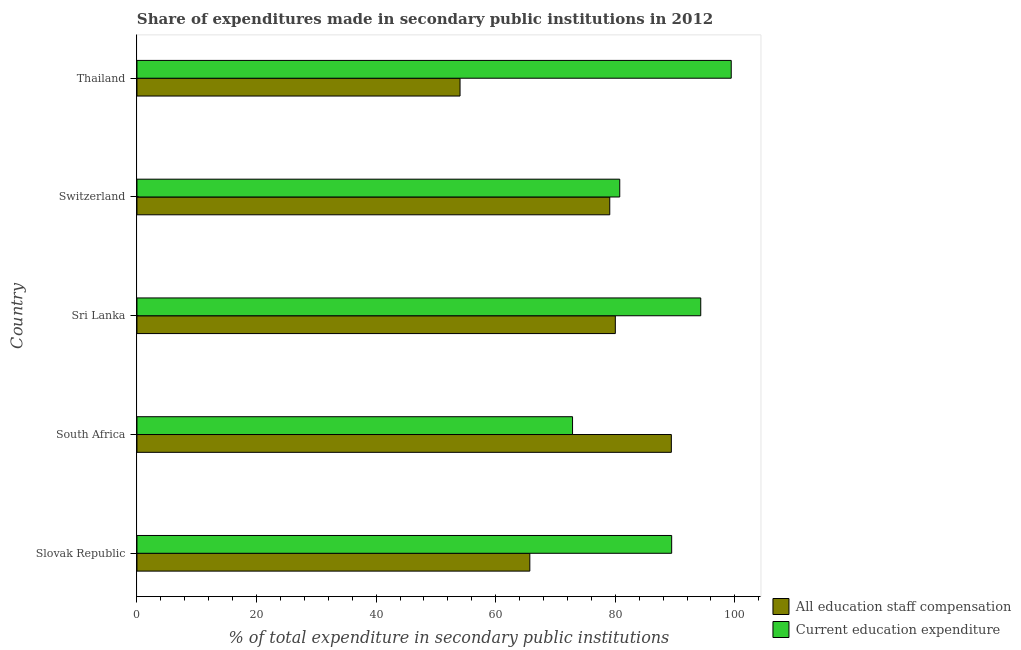Are the number of bars per tick equal to the number of legend labels?
Your response must be concise. Yes. What is the label of the 4th group of bars from the top?
Provide a succinct answer. South Africa. In how many cases, is the number of bars for a given country not equal to the number of legend labels?
Offer a very short reply. 0. What is the expenditure in education in Thailand?
Your answer should be compact. 99.39. Across all countries, what is the maximum expenditure in education?
Your response must be concise. 99.39. Across all countries, what is the minimum expenditure in staff compensation?
Offer a terse response. 54.03. In which country was the expenditure in staff compensation maximum?
Keep it short and to the point. South Africa. In which country was the expenditure in education minimum?
Provide a short and direct response. South Africa. What is the total expenditure in staff compensation in the graph?
Provide a short and direct response. 368.19. What is the difference between the expenditure in education in Sri Lanka and that in Thailand?
Ensure brevity in your answer.  -5.1. What is the difference between the expenditure in education in Sri Lanka and the expenditure in staff compensation in Thailand?
Provide a succinct answer. 40.26. What is the average expenditure in education per country?
Keep it short and to the point. 87.34. What is the difference between the expenditure in staff compensation and expenditure in education in South Africa?
Provide a succinct answer. 16.52. In how many countries, is the expenditure in staff compensation greater than 68 %?
Ensure brevity in your answer.  3. What is the ratio of the expenditure in staff compensation in Slovak Republic to that in Sri Lanka?
Your response must be concise. 0.82. Is the expenditure in staff compensation in Slovak Republic less than that in South Africa?
Ensure brevity in your answer.  Yes. What is the difference between the highest and the second highest expenditure in education?
Keep it short and to the point. 5.1. What is the difference between the highest and the lowest expenditure in staff compensation?
Ensure brevity in your answer.  35.34. In how many countries, is the expenditure in staff compensation greater than the average expenditure in staff compensation taken over all countries?
Ensure brevity in your answer.  3. Is the sum of the expenditure in staff compensation in South Africa and Thailand greater than the maximum expenditure in education across all countries?
Offer a very short reply. Yes. What does the 2nd bar from the top in Sri Lanka represents?
Give a very brief answer. All education staff compensation. What does the 2nd bar from the bottom in Thailand represents?
Offer a terse response. Current education expenditure. Are all the bars in the graph horizontal?
Your response must be concise. Yes. How many countries are there in the graph?
Your answer should be compact. 5. What is the difference between two consecutive major ticks on the X-axis?
Your answer should be compact. 20. Are the values on the major ticks of X-axis written in scientific E-notation?
Make the answer very short. No. Does the graph contain any zero values?
Offer a terse response. No. Where does the legend appear in the graph?
Offer a very short reply. Bottom right. What is the title of the graph?
Offer a very short reply. Share of expenditures made in secondary public institutions in 2012. Does "Domestic liabilities" appear as one of the legend labels in the graph?
Provide a succinct answer. No. What is the label or title of the X-axis?
Provide a succinct answer. % of total expenditure in secondary public institutions. What is the label or title of the Y-axis?
Make the answer very short. Country. What is the % of total expenditure in secondary public institutions in All education staff compensation in Slovak Republic?
Your answer should be very brief. 65.7. What is the % of total expenditure in secondary public institutions in Current education expenditure in Slovak Republic?
Offer a terse response. 89.43. What is the % of total expenditure in secondary public institutions in All education staff compensation in South Africa?
Ensure brevity in your answer.  89.37. What is the % of total expenditure in secondary public institutions of Current education expenditure in South Africa?
Your answer should be very brief. 72.85. What is the % of total expenditure in secondary public institutions in All education staff compensation in Sri Lanka?
Offer a terse response. 80. What is the % of total expenditure in secondary public institutions of Current education expenditure in Sri Lanka?
Ensure brevity in your answer.  94.29. What is the % of total expenditure in secondary public institutions in All education staff compensation in Switzerland?
Offer a very short reply. 79.07. What is the % of total expenditure in secondary public institutions in Current education expenditure in Switzerland?
Your response must be concise. 80.74. What is the % of total expenditure in secondary public institutions of All education staff compensation in Thailand?
Make the answer very short. 54.03. What is the % of total expenditure in secondary public institutions in Current education expenditure in Thailand?
Offer a very short reply. 99.39. Across all countries, what is the maximum % of total expenditure in secondary public institutions in All education staff compensation?
Your response must be concise. 89.37. Across all countries, what is the maximum % of total expenditure in secondary public institutions of Current education expenditure?
Provide a short and direct response. 99.39. Across all countries, what is the minimum % of total expenditure in secondary public institutions in All education staff compensation?
Make the answer very short. 54.03. Across all countries, what is the minimum % of total expenditure in secondary public institutions of Current education expenditure?
Your answer should be compact. 72.85. What is the total % of total expenditure in secondary public institutions in All education staff compensation in the graph?
Ensure brevity in your answer.  368.19. What is the total % of total expenditure in secondary public institutions in Current education expenditure in the graph?
Your response must be concise. 436.7. What is the difference between the % of total expenditure in secondary public institutions of All education staff compensation in Slovak Republic and that in South Africa?
Offer a terse response. -23.67. What is the difference between the % of total expenditure in secondary public institutions of Current education expenditure in Slovak Republic and that in South Africa?
Keep it short and to the point. 16.58. What is the difference between the % of total expenditure in secondary public institutions in All education staff compensation in Slovak Republic and that in Sri Lanka?
Offer a very short reply. -14.3. What is the difference between the % of total expenditure in secondary public institutions of Current education expenditure in Slovak Republic and that in Sri Lanka?
Ensure brevity in your answer.  -4.86. What is the difference between the % of total expenditure in secondary public institutions in All education staff compensation in Slovak Republic and that in Switzerland?
Your answer should be compact. -13.37. What is the difference between the % of total expenditure in secondary public institutions in Current education expenditure in Slovak Republic and that in Switzerland?
Your answer should be very brief. 8.68. What is the difference between the % of total expenditure in secondary public institutions in All education staff compensation in Slovak Republic and that in Thailand?
Give a very brief answer. 11.67. What is the difference between the % of total expenditure in secondary public institutions of Current education expenditure in Slovak Republic and that in Thailand?
Your response must be concise. -9.96. What is the difference between the % of total expenditure in secondary public institutions in All education staff compensation in South Africa and that in Sri Lanka?
Provide a succinct answer. 9.37. What is the difference between the % of total expenditure in secondary public institutions in Current education expenditure in South Africa and that in Sri Lanka?
Provide a succinct answer. -21.44. What is the difference between the % of total expenditure in secondary public institutions in All education staff compensation in South Africa and that in Switzerland?
Your answer should be compact. 10.3. What is the difference between the % of total expenditure in secondary public institutions of Current education expenditure in South Africa and that in Switzerland?
Give a very brief answer. -7.89. What is the difference between the % of total expenditure in secondary public institutions of All education staff compensation in South Africa and that in Thailand?
Offer a terse response. 35.34. What is the difference between the % of total expenditure in secondary public institutions in Current education expenditure in South Africa and that in Thailand?
Keep it short and to the point. -26.54. What is the difference between the % of total expenditure in secondary public institutions of All education staff compensation in Sri Lanka and that in Switzerland?
Your answer should be very brief. 0.93. What is the difference between the % of total expenditure in secondary public institutions of Current education expenditure in Sri Lanka and that in Switzerland?
Keep it short and to the point. 13.55. What is the difference between the % of total expenditure in secondary public institutions of All education staff compensation in Sri Lanka and that in Thailand?
Your answer should be very brief. 25.97. What is the difference between the % of total expenditure in secondary public institutions of Current education expenditure in Sri Lanka and that in Thailand?
Make the answer very short. -5.1. What is the difference between the % of total expenditure in secondary public institutions of All education staff compensation in Switzerland and that in Thailand?
Make the answer very short. 25.04. What is the difference between the % of total expenditure in secondary public institutions of Current education expenditure in Switzerland and that in Thailand?
Provide a succinct answer. -18.64. What is the difference between the % of total expenditure in secondary public institutions of All education staff compensation in Slovak Republic and the % of total expenditure in secondary public institutions of Current education expenditure in South Africa?
Your response must be concise. -7.14. What is the difference between the % of total expenditure in secondary public institutions in All education staff compensation in Slovak Republic and the % of total expenditure in secondary public institutions in Current education expenditure in Sri Lanka?
Offer a very short reply. -28.59. What is the difference between the % of total expenditure in secondary public institutions of All education staff compensation in Slovak Republic and the % of total expenditure in secondary public institutions of Current education expenditure in Switzerland?
Offer a very short reply. -15.04. What is the difference between the % of total expenditure in secondary public institutions of All education staff compensation in Slovak Republic and the % of total expenditure in secondary public institutions of Current education expenditure in Thailand?
Provide a succinct answer. -33.68. What is the difference between the % of total expenditure in secondary public institutions in All education staff compensation in South Africa and the % of total expenditure in secondary public institutions in Current education expenditure in Sri Lanka?
Ensure brevity in your answer.  -4.92. What is the difference between the % of total expenditure in secondary public institutions in All education staff compensation in South Africa and the % of total expenditure in secondary public institutions in Current education expenditure in Switzerland?
Provide a short and direct response. 8.63. What is the difference between the % of total expenditure in secondary public institutions of All education staff compensation in South Africa and the % of total expenditure in secondary public institutions of Current education expenditure in Thailand?
Ensure brevity in your answer.  -10.02. What is the difference between the % of total expenditure in secondary public institutions of All education staff compensation in Sri Lanka and the % of total expenditure in secondary public institutions of Current education expenditure in Switzerland?
Make the answer very short. -0.74. What is the difference between the % of total expenditure in secondary public institutions in All education staff compensation in Sri Lanka and the % of total expenditure in secondary public institutions in Current education expenditure in Thailand?
Offer a very short reply. -19.38. What is the difference between the % of total expenditure in secondary public institutions in All education staff compensation in Switzerland and the % of total expenditure in secondary public institutions in Current education expenditure in Thailand?
Give a very brief answer. -20.31. What is the average % of total expenditure in secondary public institutions of All education staff compensation per country?
Ensure brevity in your answer.  73.64. What is the average % of total expenditure in secondary public institutions of Current education expenditure per country?
Provide a succinct answer. 87.34. What is the difference between the % of total expenditure in secondary public institutions of All education staff compensation and % of total expenditure in secondary public institutions of Current education expenditure in Slovak Republic?
Offer a very short reply. -23.72. What is the difference between the % of total expenditure in secondary public institutions in All education staff compensation and % of total expenditure in secondary public institutions in Current education expenditure in South Africa?
Ensure brevity in your answer.  16.52. What is the difference between the % of total expenditure in secondary public institutions in All education staff compensation and % of total expenditure in secondary public institutions in Current education expenditure in Sri Lanka?
Your response must be concise. -14.29. What is the difference between the % of total expenditure in secondary public institutions in All education staff compensation and % of total expenditure in secondary public institutions in Current education expenditure in Switzerland?
Offer a very short reply. -1.67. What is the difference between the % of total expenditure in secondary public institutions of All education staff compensation and % of total expenditure in secondary public institutions of Current education expenditure in Thailand?
Your answer should be compact. -45.35. What is the ratio of the % of total expenditure in secondary public institutions in All education staff compensation in Slovak Republic to that in South Africa?
Make the answer very short. 0.74. What is the ratio of the % of total expenditure in secondary public institutions in Current education expenditure in Slovak Republic to that in South Africa?
Offer a very short reply. 1.23. What is the ratio of the % of total expenditure in secondary public institutions of All education staff compensation in Slovak Republic to that in Sri Lanka?
Your response must be concise. 0.82. What is the ratio of the % of total expenditure in secondary public institutions of Current education expenditure in Slovak Republic to that in Sri Lanka?
Keep it short and to the point. 0.95. What is the ratio of the % of total expenditure in secondary public institutions in All education staff compensation in Slovak Republic to that in Switzerland?
Keep it short and to the point. 0.83. What is the ratio of the % of total expenditure in secondary public institutions of Current education expenditure in Slovak Republic to that in Switzerland?
Make the answer very short. 1.11. What is the ratio of the % of total expenditure in secondary public institutions of All education staff compensation in Slovak Republic to that in Thailand?
Make the answer very short. 1.22. What is the ratio of the % of total expenditure in secondary public institutions of Current education expenditure in Slovak Republic to that in Thailand?
Offer a terse response. 0.9. What is the ratio of the % of total expenditure in secondary public institutions in All education staff compensation in South Africa to that in Sri Lanka?
Your answer should be compact. 1.12. What is the ratio of the % of total expenditure in secondary public institutions in Current education expenditure in South Africa to that in Sri Lanka?
Offer a very short reply. 0.77. What is the ratio of the % of total expenditure in secondary public institutions of All education staff compensation in South Africa to that in Switzerland?
Your response must be concise. 1.13. What is the ratio of the % of total expenditure in secondary public institutions in Current education expenditure in South Africa to that in Switzerland?
Your answer should be compact. 0.9. What is the ratio of the % of total expenditure in secondary public institutions in All education staff compensation in South Africa to that in Thailand?
Your answer should be very brief. 1.65. What is the ratio of the % of total expenditure in secondary public institutions of Current education expenditure in South Africa to that in Thailand?
Offer a very short reply. 0.73. What is the ratio of the % of total expenditure in secondary public institutions of All education staff compensation in Sri Lanka to that in Switzerland?
Give a very brief answer. 1.01. What is the ratio of the % of total expenditure in secondary public institutions of Current education expenditure in Sri Lanka to that in Switzerland?
Your answer should be compact. 1.17. What is the ratio of the % of total expenditure in secondary public institutions of All education staff compensation in Sri Lanka to that in Thailand?
Offer a terse response. 1.48. What is the ratio of the % of total expenditure in secondary public institutions in Current education expenditure in Sri Lanka to that in Thailand?
Provide a succinct answer. 0.95. What is the ratio of the % of total expenditure in secondary public institutions in All education staff compensation in Switzerland to that in Thailand?
Offer a very short reply. 1.46. What is the ratio of the % of total expenditure in secondary public institutions of Current education expenditure in Switzerland to that in Thailand?
Make the answer very short. 0.81. What is the difference between the highest and the second highest % of total expenditure in secondary public institutions in All education staff compensation?
Your response must be concise. 9.37. What is the difference between the highest and the second highest % of total expenditure in secondary public institutions in Current education expenditure?
Your answer should be compact. 5.1. What is the difference between the highest and the lowest % of total expenditure in secondary public institutions in All education staff compensation?
Your answer should be compact. 35.34. What is the difference between the highest and the lowest % of total expenditure in secondary public institutions in Current education expenditure?
Your answer should be compact. 26.54. 